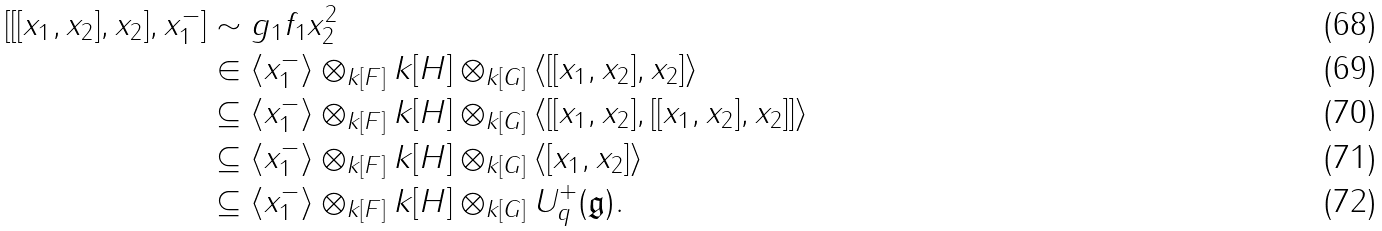Convert formula to latex. <formula><loc_0><loc_0><loc_500><loc_500>[ [ [ x _ { 1 } , x _ { 2 } ] , x _ { 2 } ] , x _ { 1 } ^ { - } ] & \sim g _ { 1 } f _ { 1 } x _ { 2 } ^ { 2 } \\ & \in \langle x _ { 1 } ^ { - } \rangle \otimes _ { k [ F ] } k [ H ] \otimes _ { k [ G ] } \langle [ [ x _ { 1 } , x _ { 2 } ] , x _ { 2 } ] \rangle \\ & \subseteq \langle x _ { 1 } ^ { - } \rangle \otimes _ { k [ F ] } k [ H ] \otimes _ { k [ G ] } \langle [ [ x _ { 1 } , x _ { 2 } ] , [ [ x _ { 1 } , x _ { 2 } ] , x _ { 2 } ] ] \rangle \\ & \subseteq \langle x _ { 1 } ^ { - } \rangle \otimes _ { k [ F ] } k [ H ] \otimes _ { k [ G ] } \langle [ x _ { 1 } , x _ { 2 } ] \rangle \\ & \subseteq \langle x _ { 1 } ^ { - } \rangle \otimes _ { k [ F ] } k [ H ] \otimes _ { k [ G ] } U _ { q } ^ { + } ( \mathfrak { g } ) .</formula> 